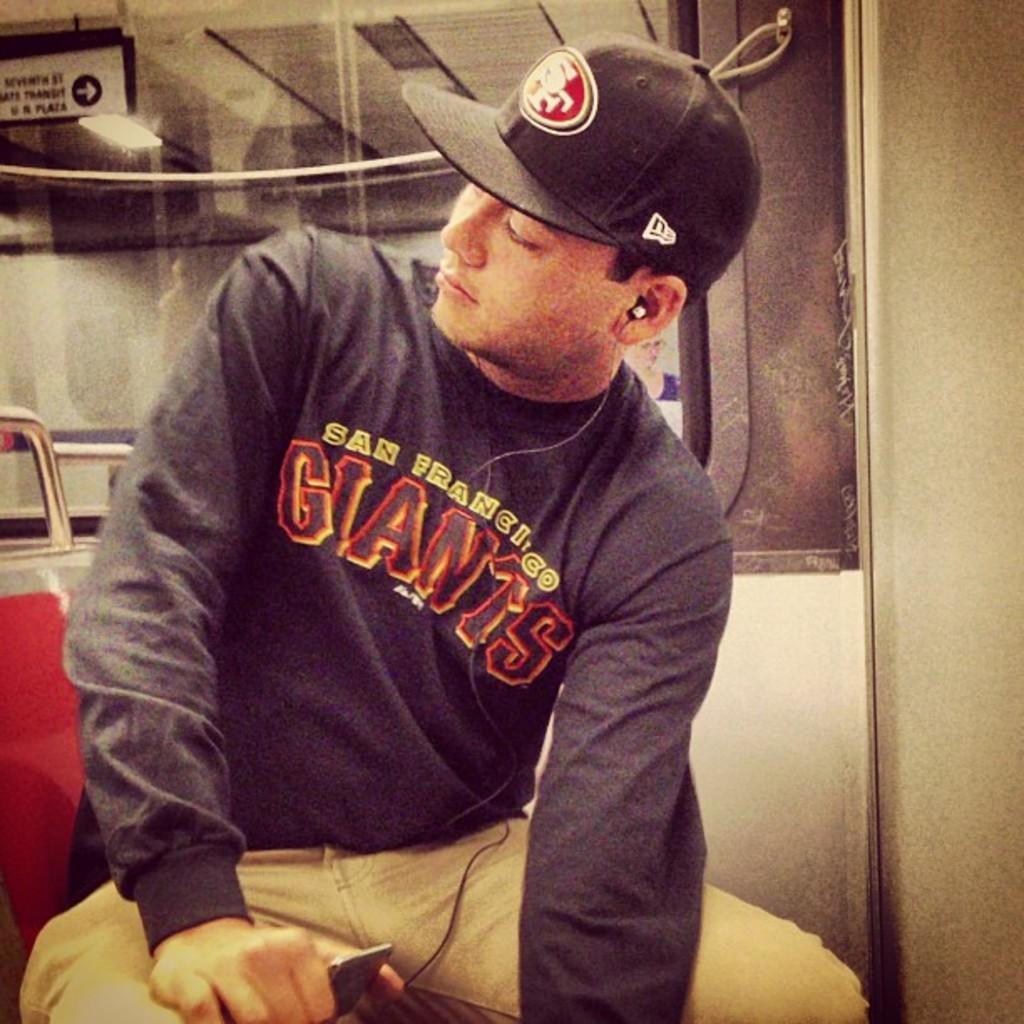Could you give a brief overview of what you see in this image? In this image we can see a person wearing a dress and a cap is holding a device in his hand. In the background, we can see a window, a sign board with some text and some lights. 